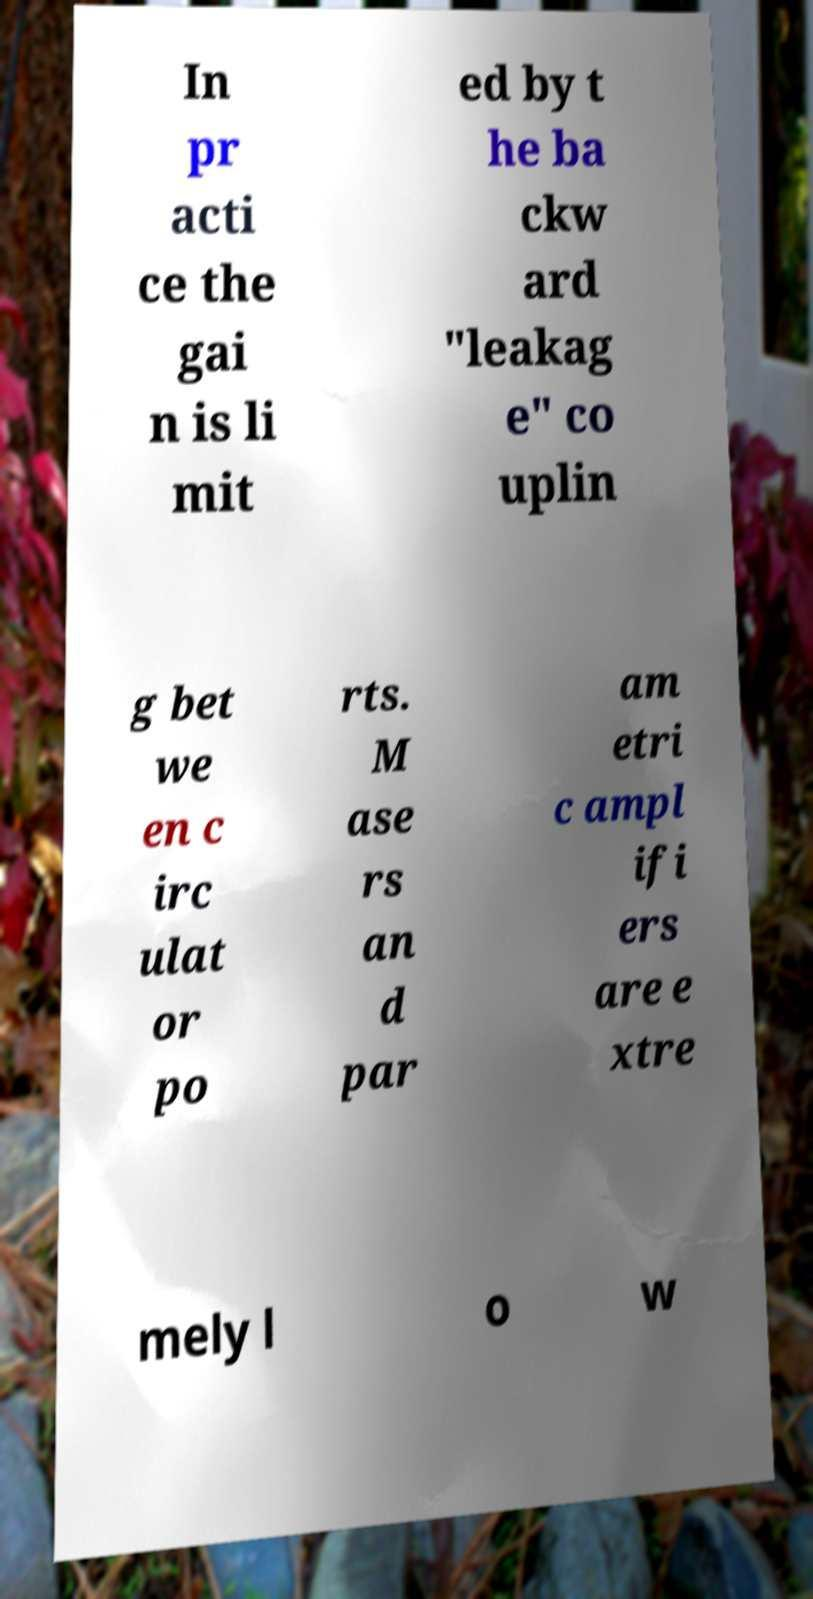Can you accurately transcribe the text from the provided image for me? In pr acti ce the gai n is li mit ed by t he ba ckw ard "leakag e" co uplin g bet we en c irc ulat or po rts. M ase rs an d par am etri c ampl ifi ers are e xtre mely l o w 